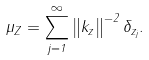<formula> <loc_0><loc_0><loc_500><loc_500>\mu _ { Z } = \sum _ { j = 1 } ^ { \infty } \left \| k _ { z } \right \| ^ { - 2 } \delta _ { z _ { j } } .</formula> 